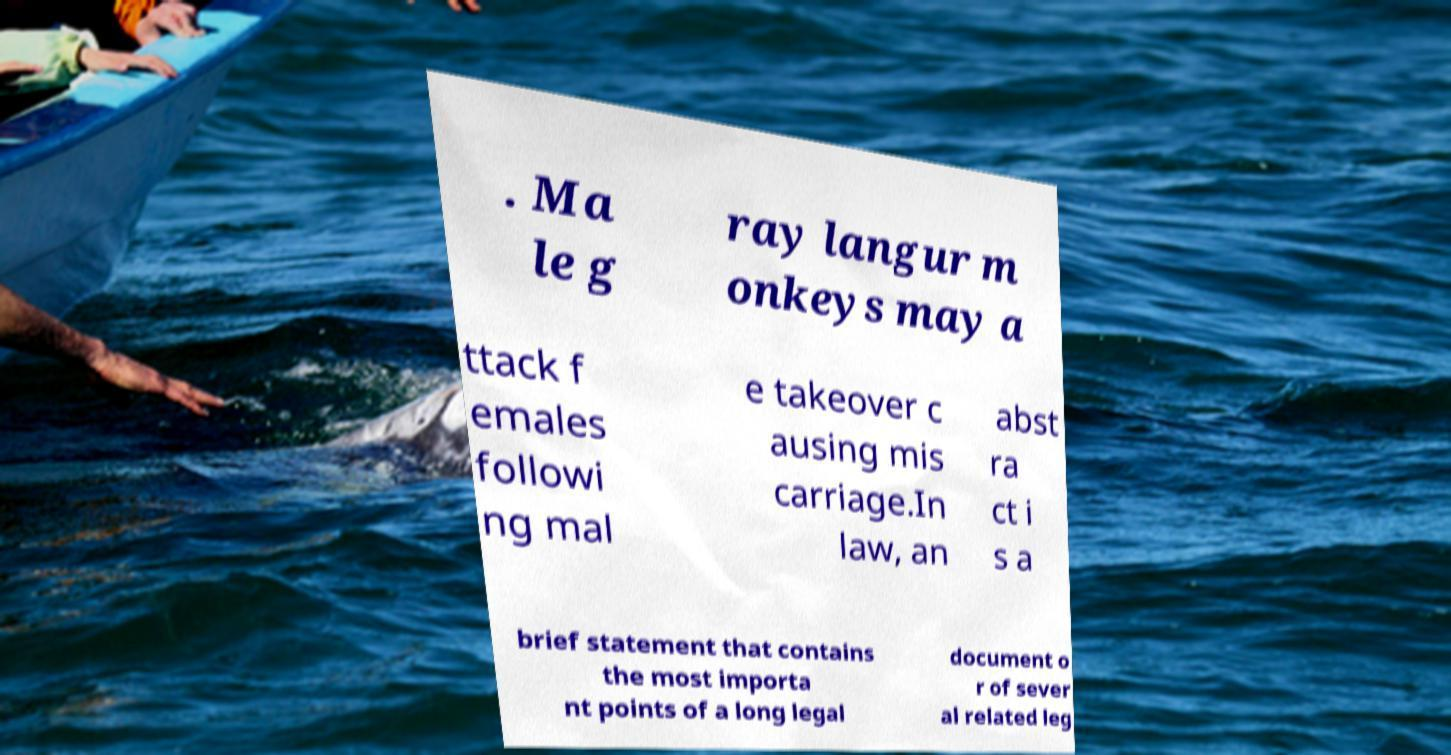Could you extract and type out the text from this image? . Ma le g ray langur m onkeys may a ttack f emales followi ng mal e takeover c ausing mis carriage.In law, an abst ra ct i s a brief statement that contains the most importa nt points of a long legal document o r of sever al related leg 